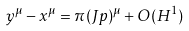<formula> <loc_0><loc_0><loc_500><loc_500>y ^ { \mu } - x ^ { \mu } = \pi ( J p ) ^ { \mu } + O ( H ^ { 1 } )</formula> 